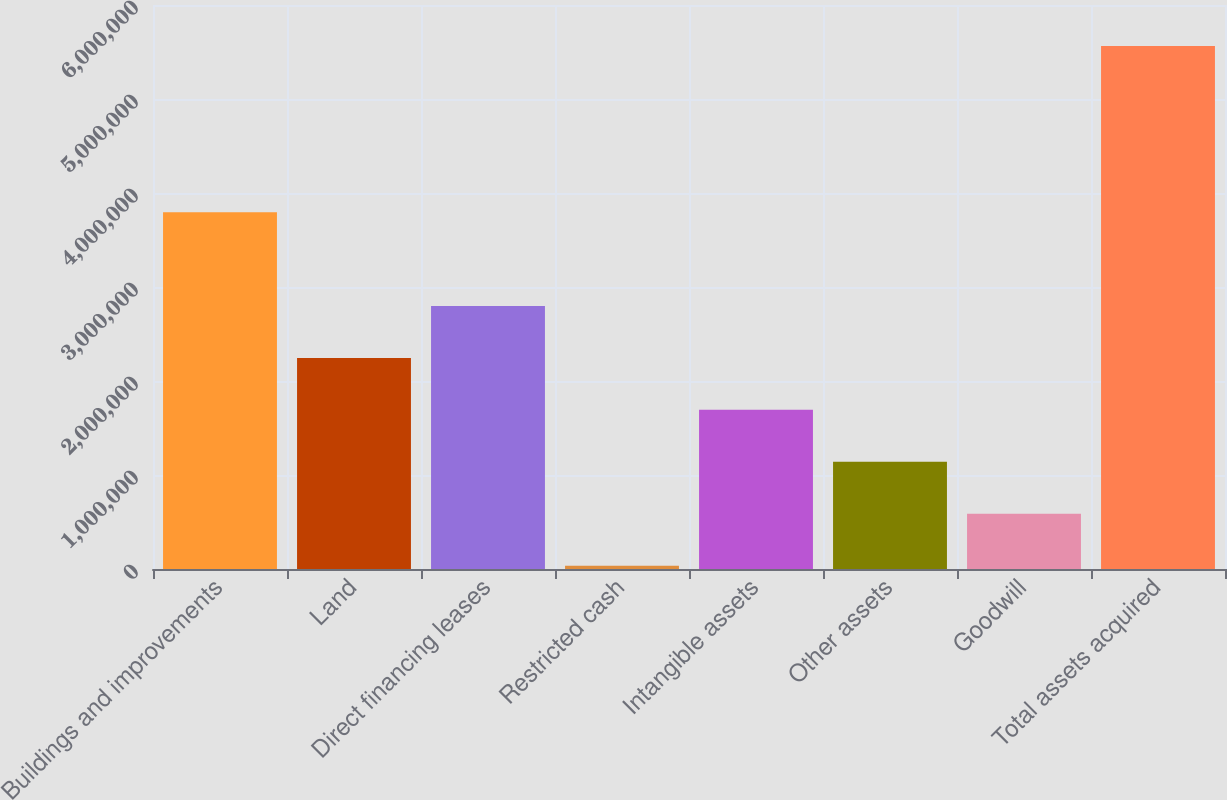<chart> <loc_0><loc_0><loc_500><loc_500><bar_chart><fcel>Buildings and improvements<fcel>Land<fcel>Direct financing leases<fcel>Restricted cash<fcel>Intangible assets<fcel>Other assets<fcel>Goodwill<fcel>Total assets acquired<nl><fcel>3.79505e+06<fcel>2.24594e+06<fcel>2.79879e+06<fcel>34566<fcel>1.6931e+06<fcel>1.14026e+06<fcel>587411<fcel>5.56301e+06<nl></chart> 